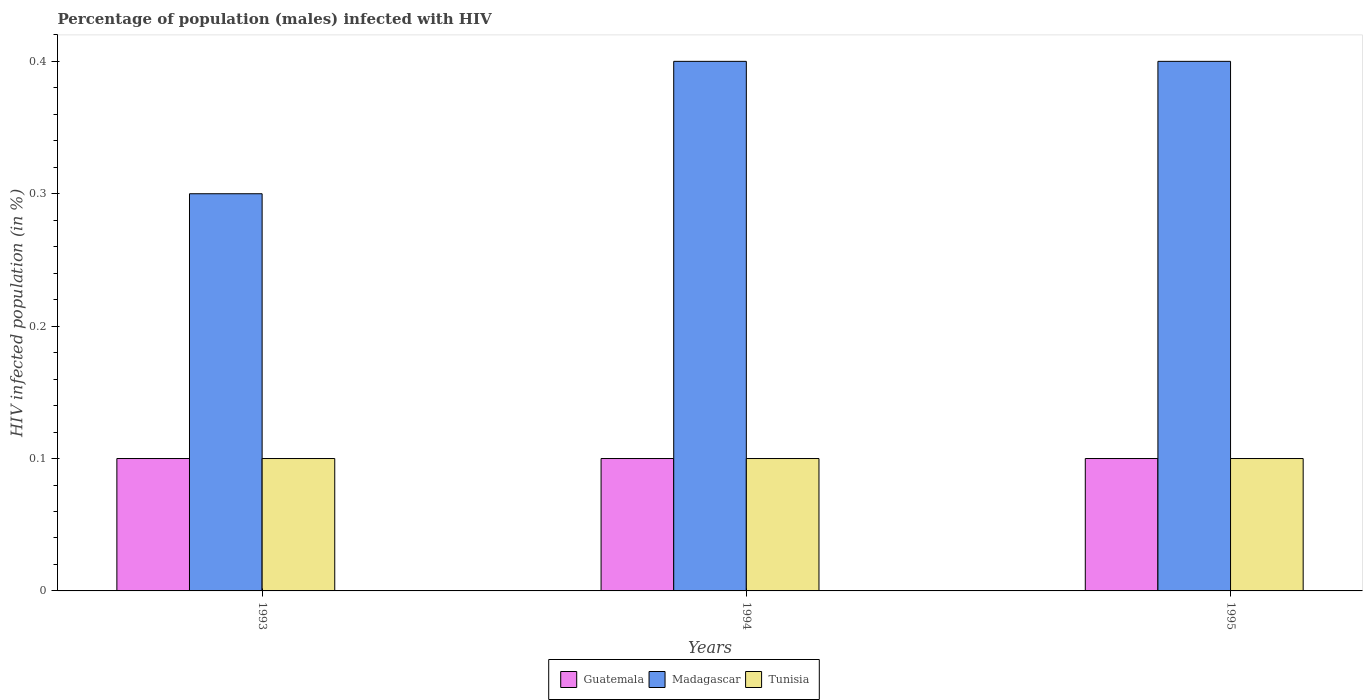How many bars are there on the 1st tick from the right?
Make the answer very short. 3. What is the label of the 1st group of bars from the left?
Provide a succinct answer. 1993. In how many cases, is the number of bars for a given year not equal to the number of legend labels?
Your answer should be very brief. 0. What is the percentage of HIV infected male population in Tunisia in 1993?
Give a very brief answer. 0.1. Across all years, what is the minimum percentage of HIV infected male population in Madagascar?
Keep it short and to the point. 0.3. In which year was the percentage of HIV infected male population in Guatemala minimum?
Your answer should be very brief. 1993. What is the total percentage of HIV infected male population in Tunisia in the graph?
Provide a short and direct response. 0.3. What is the difference between the percentage of HIV infected male population in Guatemala in 1994 and that in 1995?
Ensure brevity in your answer.  0. What is the average percentage of HIV infected male population in Tunisia per year?
Offer a terse response. 0.1. In the year 1995, what is the difference between the percentage of HIV infected male population in Madagascar and percentage of HIV infected male population in Tunisia?
Your answer should be compact. 0.3. In how many years, is the percentage of HIV infected male population in Madagascar greater than 0.24000000000000002 %?
Your answer should be very brief. 3. What is the ratio of the percentage of HIV infected male population in Guatemala in 1993 to that in 1994?
Your answer should be very brief. 1. What is the difference between the highest and the lowest percentage of HIV infected male population in Madagascar?
Ensure brevity in your answer.  0.1. Is the sum of the percentage of HIV infected male population in Tunisia in 1993 and 1995 greater than the maximum percentage of HIV infected male population in Madagascar across all years?
Keep it short and to the point. No. What does the 3rd bar from the left in 1993 represents?
Provide a succinct answer. Tunisia. What does the 3rd bar from the right in 1994 represents?
Give a very brief answer. Guatemala. How many bars are there?
Ensure brevity in your answer.  9. Does the graph contain any zero values?
Offer a terse response. No. Where does the legend appear in the graph?
Keep it short and to the point. Bottom center. How are the legend labels stacked?
Keep it short and to the point. Horizontal. What is the title of the graph?
Offer a very short reply. Percentage of population (males) infected with HIV. Does "Sub-Saharan Africa (developing only)" appear as one of the legend labels in the graph?
Provide a succinct answer. No. What is the label or title of the X-axis?
Offer a terse response. Years. What is the label or title of the Y-axis?
Provide a short and direct response. HIV infected population (in %). What is the HIV infected population (in %) in Guatemala in 1993?
Provide a succinct answer. 0.1. What is the HIV infected population (in %) of Madagascar in 1993?
Provide a short and direct response. 0.3. What is the HIV infected population (in %) in Guatemala in 1994?
Offer a very short reply. 0.1. What is the HIV infected population (in %) in Madagascar in 1994?
Keep it short and to the point. 0.4. What is the HIV infected population (in %) of Tunisia in 1994?
Keep it short and to the point. 0.1. Across all years, what is the maximum HIV infected population (in %) in Tunisia?
Provide a succinct answer. 0.1. Across all years, what is the minimum HIV infected population (in %) in Tunisia?
Give a very brief answer. 0.1. What is the total HIV infected population (in %) of Madagascar in the graph?
Keep it short and to the point. 1.1. What is the total HIV infected population (in %) of Tunisia in the graph?
Your response must be concise. 0.3. What is the difference between the HIV infected population (in %) of Madagascar in 1993 and that in 1994?
Provide a succinct answer. -0.1. What is the difference between the HIV infected population (in %) of Tunisia in 1993 and that in 1994?
Offer a very short reply. 0. What is the difference between the HIV infected population (in %) in Guatemala in 1993 and that in 1995?
Ensure brevity in your answer.  0. What is the difference between the HIV infected population (in %) of Tunisia in 1993 and that in 1995?
Provide a succinct answer. 0. What is the difference between the HIV infected population (in %) of Guatemala in 1993 and the HIV infected population (in %) of Madagascar in 1994?
Provide a short and direct response. -0.3. What is the difference between the HIV infected population (in %) of Madagascar in 1993 and the HIV infected population (in %) of Tunisia in 1994?
Keep it short and to the point. 0.2. What is the difference between the HIV infected population (in %) of Madagascar in 1994 and the HIV infected population (in %) of Tunisia in 1995?
Offer a very short reply. 0.3. What is the average HIV infected population (in %) in Madagascar per year?
Ensure brevity in your answer.  0.37. What is the average HIV infected population (in %) of Tunisia per year?
Your answer should be very brief. 0.1. In the year 1993, what is the difference between the HIV infected population (in %) in Guatemala and HIV infected population (in %) in Madagascar?
Your answer should be compact. -0.2. In the year 1993, what is the difference between the HIV infected population (in %) of Madagascar and HIV infected population (in %) of Tunisia?
Keep it short and to the point. 0.2. In the year 1995, what is the difference between the HIV infected population (in %) in Guatemala and HIV infected population (in %) in Tunisia?
Provide a short and direct response. 0. What is the ratio of the HIV infected population (in %) of Madagascar in 1993 to that in 1994?
Offer a terse response. 0.75. What is the ratio of the HIV infected population (in %) in Tunisia in 1993 to that in 1994?
Give a very brief answer. 1. What is the ratio of the HIV infected population (in %) in Madagascar in 1993 to that in 1995?
Provide a succinct answer. 0.75. What is the ratio of the HIV infected population (in %) of Tunisia in 1993 to that in 1995?
Ensure brevity in your answer.  1. What is the ratio of the HIV infected population (in %) of Tunisia in 1994 to that in 1995?
Offer a terse response. 1. What is the difference between the highest and the second highest HIV infected population (in %) in Guatemala?
Your response must be concise. 0. What is the difference between the highest and the second highest HIV infected population (in %) of Madagascar?
Keep it short and to the point. 0. What is the difference between the highest and the lowest HIV infected population (in %) of Guatemala?
Ensure brevity in your answer.  0. What is the difference between the highest and the lowest HIV infected population (in %) of Tunisia?
Your response must be concise. 0. 